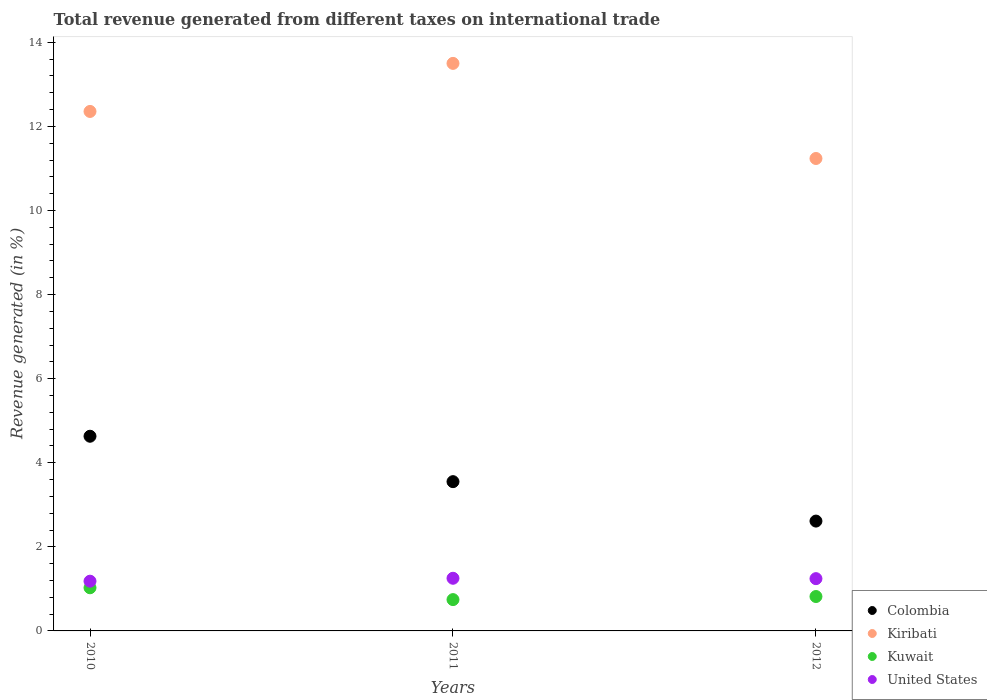Is the number of dotlines equal to the number of legend labels?
Provide a succinct answer. Yes. What is the total revenue generated in Colombia in 2010?
Your answer should be compact. 4.63. Across all years, what is the maximum total revenue generated in Kiribati?
Provide a succinct answer. 13.5. Across all years, what is the minimum total revenue generated in Kuwait?
Your answer should be very brief. 0.74. In which year was the total revenue generated in Colombia maximum?
Your answer should be very brief. 2010. In which year was the total revenue generated in Colombia minimum?
Offer a very short reply. 2012. What is the total total revenue generated in Kiribati in the graph?
Your answer should be very brief. 37.09. What is the difference between the total revenue generated in United States in 2010 and that in 2012?
Your response must be concise. -0.06. What is the difference between the total revenue generated in Kuwait in 2010 and the total revenue generated in Colombia in 2012?
Give a very brief answer. -1.59. What is the average total revenue generated in Colombia per year?
Offer a terse response. 3.6. In the year 2010, what is the difference between the total revenue generated in Colombia and total revenue generated in Kuwait?
Keep it short and to the point. 3.6. What is the ratio of the total revenue generated in Colombia in 2010 to that in 2012?
Give a very brief answer. 1.77. Is the difference between the total revenue generated in Colombia in 2010 and 2012 greater than the difference between the total revenue generated in Kuwait in 2010 and 2012?
Your response must be concise. Yes. What is the difference between the highest and the second highest total revenue generated in Kiribati?
Give a very brief answer. 1.14. What is the difference between the highest and the lowest total revenue generated in Kiribati?
Provide a short and direct response. 2.26. Is it the case that in every year, the sum of the total revenue generated in Colombia and total revenue generated in United States  is greater than the sum of total revenue generated in Kuwait and total revenue generated in Kiribati?
Your response must be concise. Yes. Does the total revenue generated in Kuwait monotonically increase over the years?
Offer a terse response. No. Is the total revenue generated in Kiribati strictly greater than the total revenue generated in Colombia over the years?
Provide a short and direct response. Yes. Is the total revenue generated in Kiribati strictly less than the total revenue generated in United States over the years?
Give a very brief answer. No. How many years are there in the graph?
Make the answer very short. 3. What is the difference between two consecutive major ticks on the Y-axis?
Give a very brief answer. 2. Are the values on the major ticks of Y-axis written in scientific E-notation?
Give a very brief answer. No. Does the graph contain any zero values?
Your response must be concise. No. How many legend labels are there?
Your answer should be very brief. 4. How are the legend labels stacked?
Ensure brevity in your answer.  Vertical. What is the title of the graph?
Give a very brief answer. Total revenue generated from different taxes on international trade. Does "Kosovo" appear as one of the legend labels in the graph?
Give a very brief answer. No. What is the label or title of the X-axis?
Give a very brief answer. Years. What is the label or title of the Y-axis?
Provide a succinct answer. Revenue generated (in %). What is the Revenue generated (in %) in Colombia in 2010?
Give a very brief answer. 4.63. What is the Revenue generated (in %) in Kiribati in 2010?
Your response must be concise. 12.36. What is the Revenue generated (in %) in Kuwait in 2010?
Your answer should be compact. 1.03. What is the Revenue generated (in %) in United States in 2010?
Give a very brief answer. 1.18. What is the Revenue generated (in %) of Colombia in 2011?
Keep it short and to the point. 3.55. What is the Revenue generated (in %) in Kiribati in 2011?
Provide a short and direct response. 13.5. What is the Revenue generated (in %) of Kuwait in 2011?
Offer a terse response. 0.74. What is the Revenue generated (in %) in United States in 2011?
Provide a short and direct response. 1.25. What is the Revenue generated (in %) of Colombia in 2012?
Offer a very short reply. 2.61. What is the Revenue generated (in %) in Kiribati in 2012?
Give a very brief answer. 11.24. What is the Revenue generated (in %) of Kuwait in 2012?
Offer a very short reply. 0.82. What is the Revenue generated (in %) in United States in 2012?
Provide a succinct answer. 1.24. Across all years, what is the maximum Revenue generated (in %) of Colombia?
Ensure brevity in your answer.  4.63. Across all years, what is the maximum Revenue generated (in %) of Kiribati?
Ensure brevity in your answer.  13.5. Across all years, what is the maximum Revenue generated (in %) in Kuwait?
Provide a succinct answer. 1.03. Across all years, what is the maximum Revenue generated (in %) of United States?
Keep it short and to the point. 1.25. Across all years, what is the minimum Revenue generated (in %) of Colombia?
Offer a very short reply. 2.61. Across all years, what is the minimum Revenue generated (in %) in Kiribati?
Provide a short and direct response. 11.24. Across all years, what is the minimum Revenue generated (in %) of Kuwait?
Give a very brief answer. 0.74. Across all years, what is the minimum Revenue generated (in %) in United States?
Your response must be concise. 1.18. What is the total Revenue generated (in %) of Colombia in the graph?
Keep it short and to the point. 10.79. What is the total Revenue generated (in %) of Kiribati in the graph?
Make the answer very short. 37.09. What is the total Revenue generated (in %) in Kuwait in the graph?
Give a very brief answer. 2.59. What is the total Revenue generated (in %) in United States in the graph?
Offer a terse response. 3.68. What is the difference between the Revenue generated (in %) of Colombia in 2010 and that in 2011?
Provide a succinct answer. 1.08. What is the difference between the Revenue generated (in %) of Kiribati in 2010 and that in 2011?
Your answer should be compact. -1.14. What is the difference between the Revenue generated (in %) in Kuwait in 2010 and that in 2011?
Make the answer very short. 0.28. What is the difference between the Revenue generated (in %) in United States in 2010 and that in 2011?
Your response must be concise. -0.07. What is the difference between the Revenue generated (in %) in Colombia in 2010 and that in 2012?
Make the answer very short. 2.02. What is the difference between the Revenue generated (in %) of Kiribati in 2010 and that in 2012?
Your answer should be very brief. 1.12. What is the difference between the Revenue generated (in %) of Kuwait in 2010 and that in 2012?
Keep it short and to the point. 0.21. What is the difference between the Revenue generated (in %) in United States in 2010 and that in 2012?
Your answer should be very brief. -0.06. What is the difference between the Revenue generated (in %) of Colombia in 2011 and that in 2012?
Give a very brief answer. 0.94. What is the difference between the Revenue generated (in %) of Kiribati in 2011 and that in 2012?
Give a very brief answer. 2.26. What is the difference between the Revenue generated (in %) of Kuwait in 2011 and that in 2012?
Your answer should be compact. -0.07. What is the difference between the Revenue generated (in %) in United States in 2011 and that in 2012?
Your answer should be very brief. 0.01. What is the difference between the Revenue generated (in %) of Colombia in 2010 and the Revenue generated (in %) of Kiribati in 2011?
Your response must be concise. -8.87. What is the difference between the Revenue generated (in %) in Colombia in 2010 and the Revenue generated (in %) in Kuwait in 2011?
Keep it short and to the point. 3.89. What is the difference between the Revenue generated (in %) in Colombia in 2010 and the Revenue generated (in %) in United States in 2011?
Your response must be concise. 3.38. What is the difference between the Revenue generated (in %) in Kiribati in 2010 and the Revenue generated (in %) in Kuwait in 2011?
Give a very brief answer. 11.61. What is the difference between the Revenue generated (in %) in Kiribati in 2010 and the Revenue generated (in %) in United States in 2011?
Provide a succinct answer. 11.1. What is the difference between the Revenue generated (in %) of Kuwait in 2010 and the Revenue generated (in %) of United States in 2011?
Ensure brevity in your answer.  -0.23. What is the difference between the Revenue generated (in %) of Colombia in 2010 and the Revenue generated (in %) of Kiribati in 2012?
Offer a terse response. -6.61. What is the difference between the Revenue generated (in %) in Colombia in 2010 and the Revenue generated (in %) in Kuwait in 2012?
Provide a short and direct response. 3.81. What is the difference between the Revenue generated (in %) in Colombia in 2010 and the Revenue generated (in %) in United States in 2012?
Your answer should be very brief. 3.39. What is the difference between the Revenue generated (in %) in Kiribati in 2010 and the Revenue generated (in %) in Kuwait in 2012?
Your response must be concise. 11.54. What is the difference between the Revenue generated (in %) of Kiribati in 2010 and the Revenue generated (in %) of United States in 2012?
Make the answer very short. 11.11. What is the difference between the Revenue generated (in %) in Kuwait in 2010 and the Revenue generated (in %) in United States in 2012?
Keep it short and to the point. -0.22. What is the difference between the Revenue generated (in %) of Colombia in 2011 and the Revenue generated (in %) of Kiribati in 2012?
Ensure brevity in your answer.  -7.69. What is the difference between the Revenue generated (in %) in Colombia in 2011 and the Revenue generated (in %) in Kuwait in 2012?
Offer a very short reply. 2.73. What is the difference between the Revenue generated (in %) of Colombia in 2011 and the Revenue generated (in %) of United States in 2012?
Offer a terse response. 2.31. What is the difference between the Revenue generated (in %) of Kiribati in 2011 and the Revenue generated (in %) of Kuwait in 2012?
Offer a very short reply. 12.68. What is the difference between the Revenue generated (in %) of Kiribati in 2011 and the Revenue generated (in %) of United States in 2012?
Offer a terse response. 12.26. What is the difference between the Revenue generated (in %) of Kuwait in 2011 and the Revenue generated (in %) of United States in 2012?
Make the answer very short. -0.5. What is the average Revenue generated (in %) in Colombia per year?
Give a very brief answer. 3.6. What is the average Revenue generated (in %) in Kiribati per year?
Keep it short and to the point. 12.36. What is the average Revenue generated (in %) of Kuwait per year?
Offer a terse response. 0.86. What is the average Revenue generated (in %) in United States per year?
Give a very brief answer. 1.23. In the year 2010, what is the difference between the Revenue generated (in %) in Colombia and Revenue generated (in %) in Kiribati?
Keep it short and to the point. -7.72. In the year 2010, what is the difference between the Revenue generated (in %) of Colombia and Revenue generated (in %) of Kuwait?
Make the answer very short. 3.6. In the year 2010, what is the difference between the Revenue generated (in %) of Colombia and Revenue generated (in %) of United States?
Your response must be concise. 3.45. In the year 2010, what is the difference between the Revenue generated (in %) of Kiribati and Revenue generated (in %) of Kuwait?
Give a very brief answer. 11.33. In the year 2010, what is the difference between the Revenue generated (in %) of Kiribati and Revenue generated (in %) of United States?
Provide a succinct answer. 11.17. In the year 2010, what is the difference between the Revenue generated (in %) of Kuwait and Revenue generated (in %) of United States?
Make the answer very short. -0.16. In the year 2011, what is the difference between the Revenue generated (in %) in Colombia and Revenue generated (in %) in Kiribati?
Offer a very short reply. -9.95. In the year 2011, what is the difference between the Revenue generated (in %) in Colombia and Revenue generated (in %) in Kuwait?
Ensure brevity in your answer.  2.81. In the year 2011, what is the difference between the Revenue generated (in %) of Colombia and Revenue generated (in %) of United States?
Your answer should be very brief. 2.3. In the year 2011, what is the difference between the Revenue generated (in %) in Kiribati and Revenue generated (in %) in Kuwait?
Offer a very short reply. 12.75. In the year 2011, what is the difference between the Revenue generated (in %) of Kiribati and Revenue generated (in %) of United States?
Ensure brevity in your answer.  12.25. In the year 2011, what is the difference between the Revenue generated (in %) in Kuwait and Revenue generated (in %) in United States?
Keep it short and to the point. -0.51. In the year 2012, what is the difference between the Revenue generated (in %) of Colombia and Revenue generated (in %) of Kiribati?
Offer a very short reply. -8.62. In the year 2012, what is the difference between the Revenue generated (in %) of Colombia and Revenue generated (in %) of Kuwait?
Offer a very short reply. 1.79. In the year 2012, what is the difference between the Revenue generated (in %) in Colombia and Revenue generated (in %) in United States?
Offer a terse response. 1.37. In the year 2012, what is the difference between the Revenue generated (in %) in Kiribati and Revenue generated (in %) in Kuwait?
Your answer should be very brief. 10.42. In the year 2012, what is the difference between the Revenue generated (in %) of Kiribati and Revenue generated (in %) of United States?
Your answer should be compact. 9.99. In the year 2012, what is the difference between the Revenue generated (in %) of Kuwait and Revenue generated (in %) of United States?
Provide a short and direct response. -0.43. What is the ratio of the Revenue generated (in %) of Colombia in 2010 to that in 2011?
Offer a terse response. 1.3. What is the ratio of the Revenue generated (in %) of Kiribati in 2010 to that in 2011?
Offer a very short reply. 0.92. What is the ratio of the Revenue generated (in %) of Kuwait in 2010 to that in 2011?
Your answer should be very brief. 1.38. What is the ratio of the Revenue generated (in %) in United States in 2010 to that in 2011?
Offer a very short reply. 0.94. What is the ratio of the Revenue generated (in %) of Colombia in 2010 to that in 2012?
Your answer should be compact. 1.77. What is the ratio of the Revenue generated (in %) of Kiribati in 2010 to that in 2012?
Your response must be concise. 1.1. What is the ratio of the Revenue generated (in %) of Kuwait in 2010 to that in 2012?
Give a very brief answer. 1.25. What is the ratio of the Revenue generated (in %) of United States in 2010 to that in 2012?
Offer a very short reply. 0.95. What is the ratio of the Revenue generated (in %) in Colombia in 2011 to that in 2012?
Your response must be concise. 1.36. What is the ratio of the Revenue generated (in %) of Kiribati in 2011 to that in 2012?
Give a very brief answer. 1.2. What is the ratio of the Revenue generated (in %) of Kuwait in 2011 to that in 2012?
Your answer should be compact. 0.91. What is the difference between the highest and the second highest Revenue generated (in %) of Colombia?
Your answer should be very brief. 1.08. What is the difference between the highest and the second highest Revenue generated (in %) of Kiribati?
Provide a succinct answer. 1.14. What is the difference between the highest and the second highest Revenue generated (in %) of Kuwait?
Your response must be concise. 0.21. What is the difference between the highest and the second highest Revenue generated (in %) in United States?
Offer a terse response. 0.01. What is the difference between the highest and the lowest Revenue generated (in %) in Colombia?
Provide a succinct answer. 2.02. What is the difference between the highest and the lowest Revenue generated (in %) of Kiribati?
Offer a very short reply. 2.26. What is the difference between the highest and the lowest Revenue generated (in %) of Kuwait?
Provide a short and direct response. 0.28. What is the difference between the highest and the lowest Revenue generated (in %) of United States?
Provide a succinct answer. 0.07. 